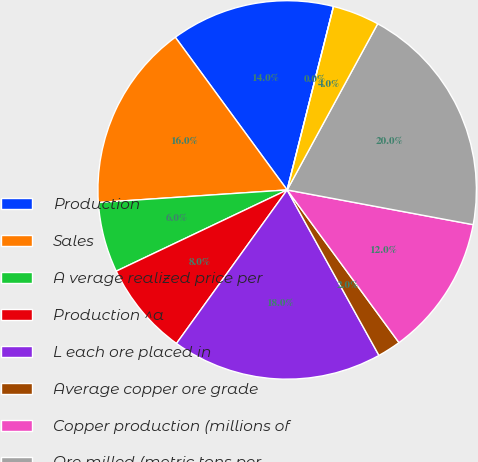Convert chart to OTSL. <chart><loc_0><loc_0><loc_500><loc_500><pie_chart><fcel>Production<fcel>Sales<fcel>A verage realized price per<fcel>Production ^a<fcel>L each ore placed in<fcel>Average copper ore grade<fcel>Copper production (millions of<fcel>Ore milled (metric tons per<fcel>Copper<fcel>Molybdenum<nl><fcel>14.0%<fcel>16.0%<fcel>6.0%<fcel>8.0%<fcel>18.0%<fcel>2.0%<fcel>12.0%<fcel>20.0%<fcel>4.0%<fcel>0.0%<nl></chart> 